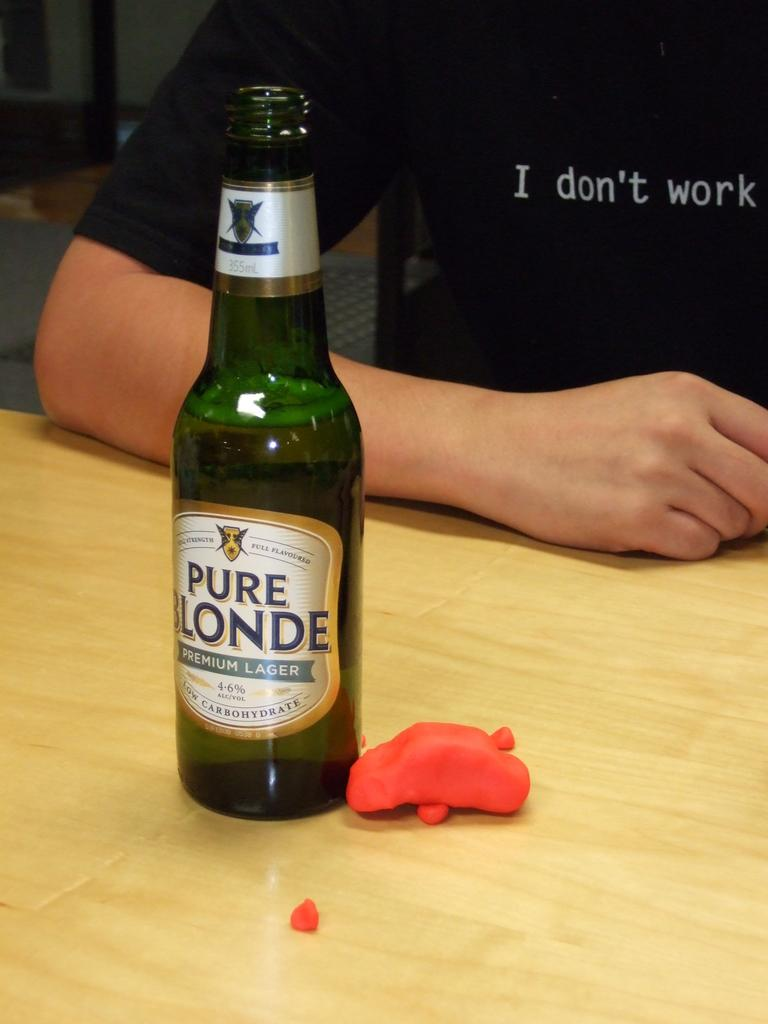<image>
Relay a brief, clear account of the picture shown. A bottle of Pure Londe sits on a table next to some red playdough 